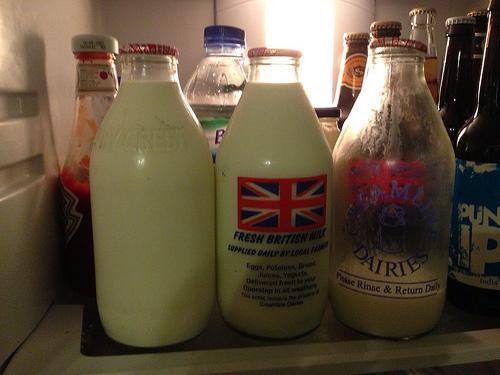How many red bottles are there?
Give a very brief answer. 0. 